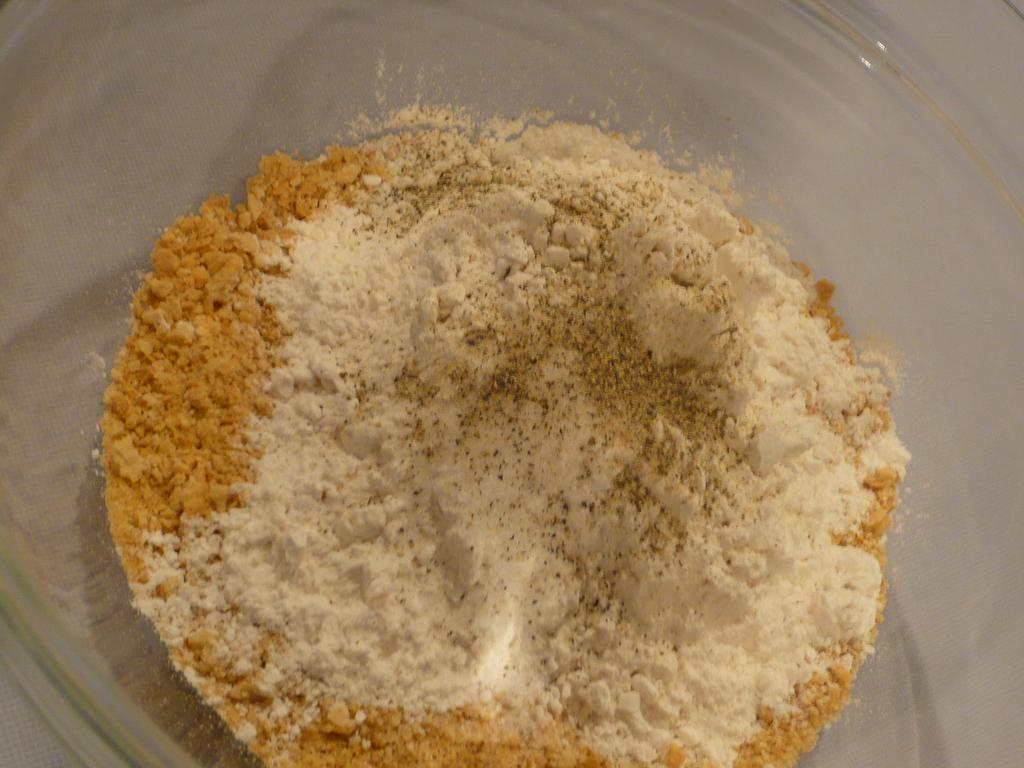What is in the image? There is a bowl in the image. What is inside the bowl? There are powders in the bowl. How many attempts were made to open the box in the image? There is no box present in the image, so it is not possible to determine the number of attempts made to open it. 